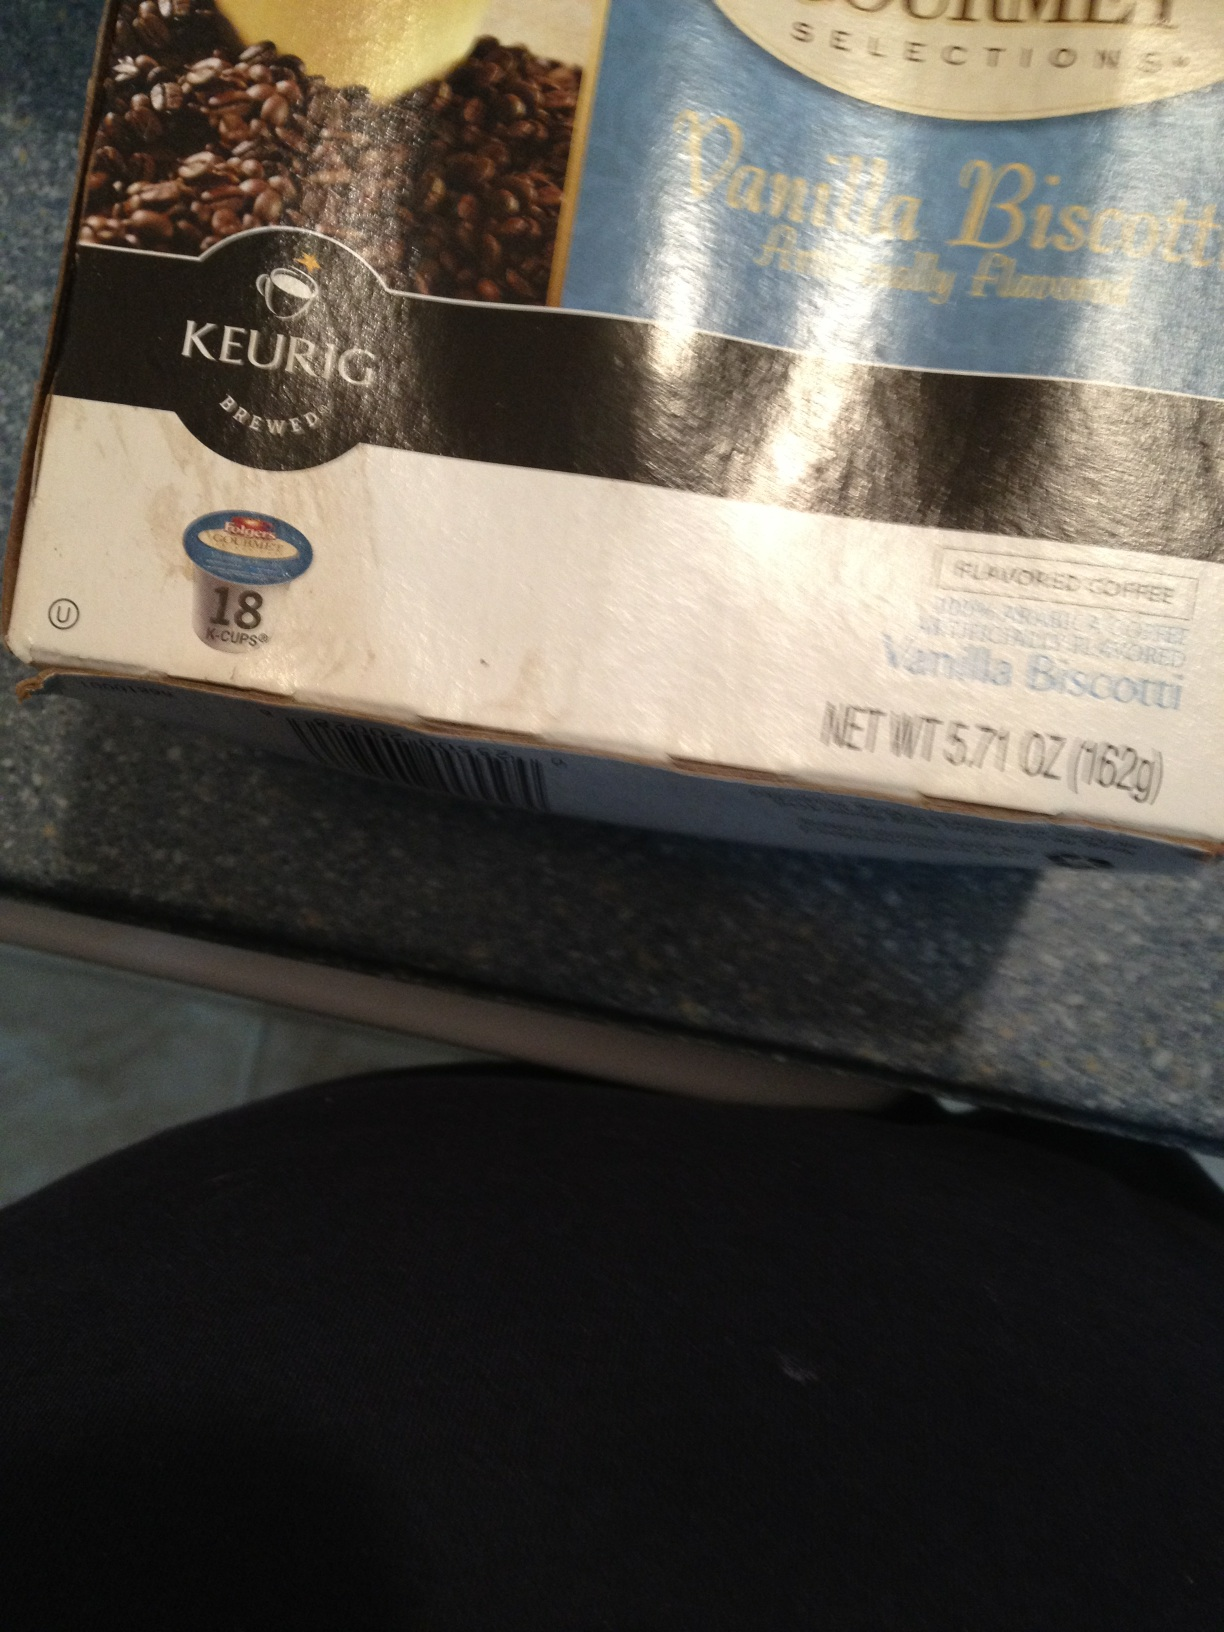If this flavor was a character in a story, what would they be like? If Vanilla Biscotti were a character in a story, it would be a charming and warm individual, possibly a barista who brings a touch of sweetness to everyone’s lives. This character would be known for their comforting presence, always ready to share a cup of coffee infused with delightful vanilla and biscotti notes, spreading joy and calm with every sip. 